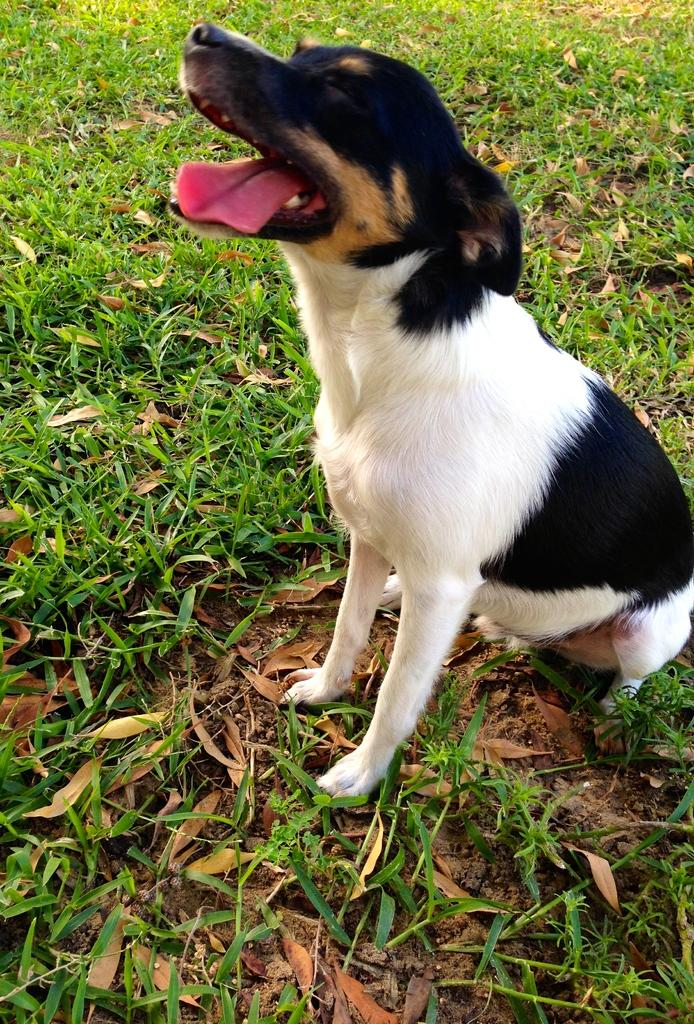What animal can be seen in the picture? There is a dog in the picture. What is the dog doing in the picture? The dog is sitting on the ground. What type of environment is visible in the background of the picture? There is grass visible in the background of the picture. What level of power does the dog have in the image? The image does not depict the dog having any power or authority, so it cannot be determined from the image. 